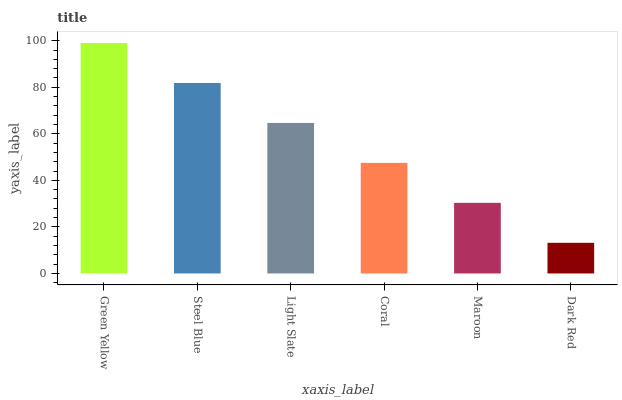Is Dark Red the minimum?
Answer yes or no. Yes. Is Green Yellow the maximum?
Answer yes or no. Yes. Is Steel Blue the minimum?
Answer yes or no. No. Is Steel Blue the maximum?
Answer yes or no. No. Is Green Yellow greater than Steel Blue?
Answer yes or no. Yes. Is Steel Blue less than Green Yellow?
Answer yes or no. Yes. Is Steel Blue greater than Green Yellow?
Answer yes or no. No. Is Green Yellow less than Steel Blue?
Answer yes or no. No. Is Light Slate the high median?
Answer yes or no. Yes. Is Coral the low median?
Answer yes or no. Yes. Is Maroon the high median?
Answer yes or no. No. Is Green Yellow the low median?
Answer yes or no. No. 